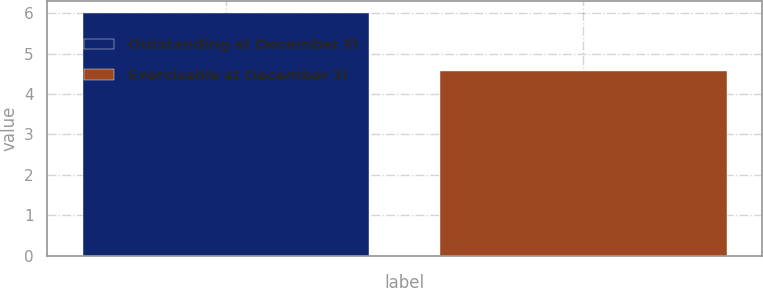Convert chart. <chart><loc_0><loc_0><loc_500><loc_500><bar_chart><fcel>Outstanding at December 31<fcel>Exercisable at December 31<nl><fcel>6<fcel>4.56<nl></chart> 